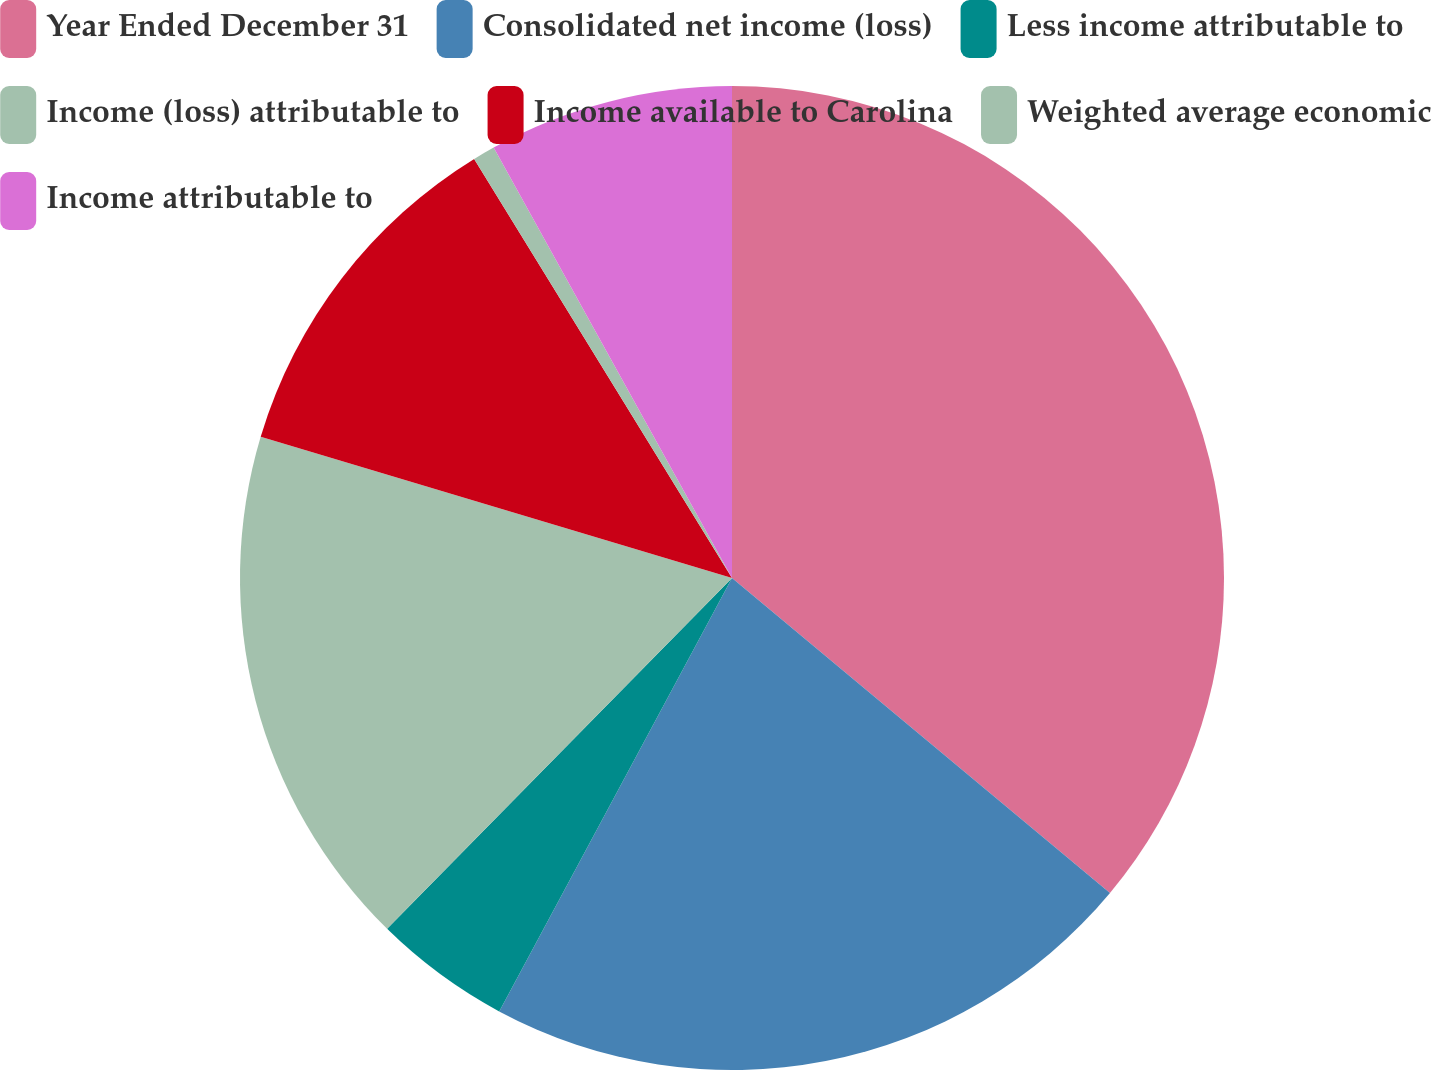Convert chart. <chart><loc_0><loc_0><loc_500><loc_500><pie_chart><fcel>Year Ended December 31<fcel>Consolidated net income (loss)<fcel>Less income attributable to<fcel>Income (loss) attributable to<fcel>Income available to Carolina<fcel>Weighted average economic<fcel>Income attributable to<nl><fcel>36.06%<fcel>21.79%<fcel>4.52%<fcel>17.27%<fcel>11.59%<fcel>0.73%<fcel>8.05%<nl></chart> 